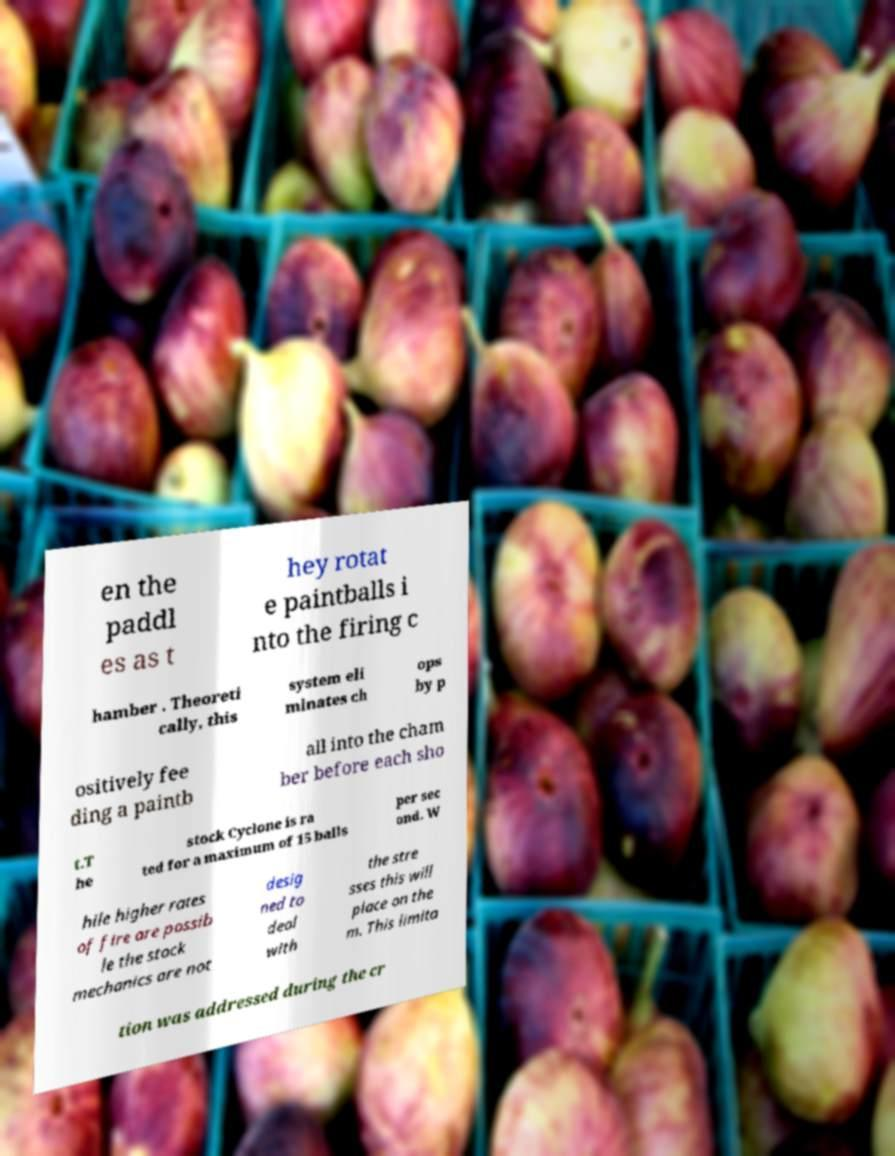Please read and relay the text visible in this image. What does it say? en the paddl es as t hey rotat e paintballs i nto the firing c hamber . Theoreti cally, this system eli minates ch ops by p ositively fee ding a paintb all into the cham ber before each sho t.T he stock Cyclone is ra ted for a maximum of 15 balls per sec ond. W hile higher rates of fire are possib le the stock mechanics are not desig ned to deal with the stre sses this will place on the m. This limita tion was addressed during the cr 